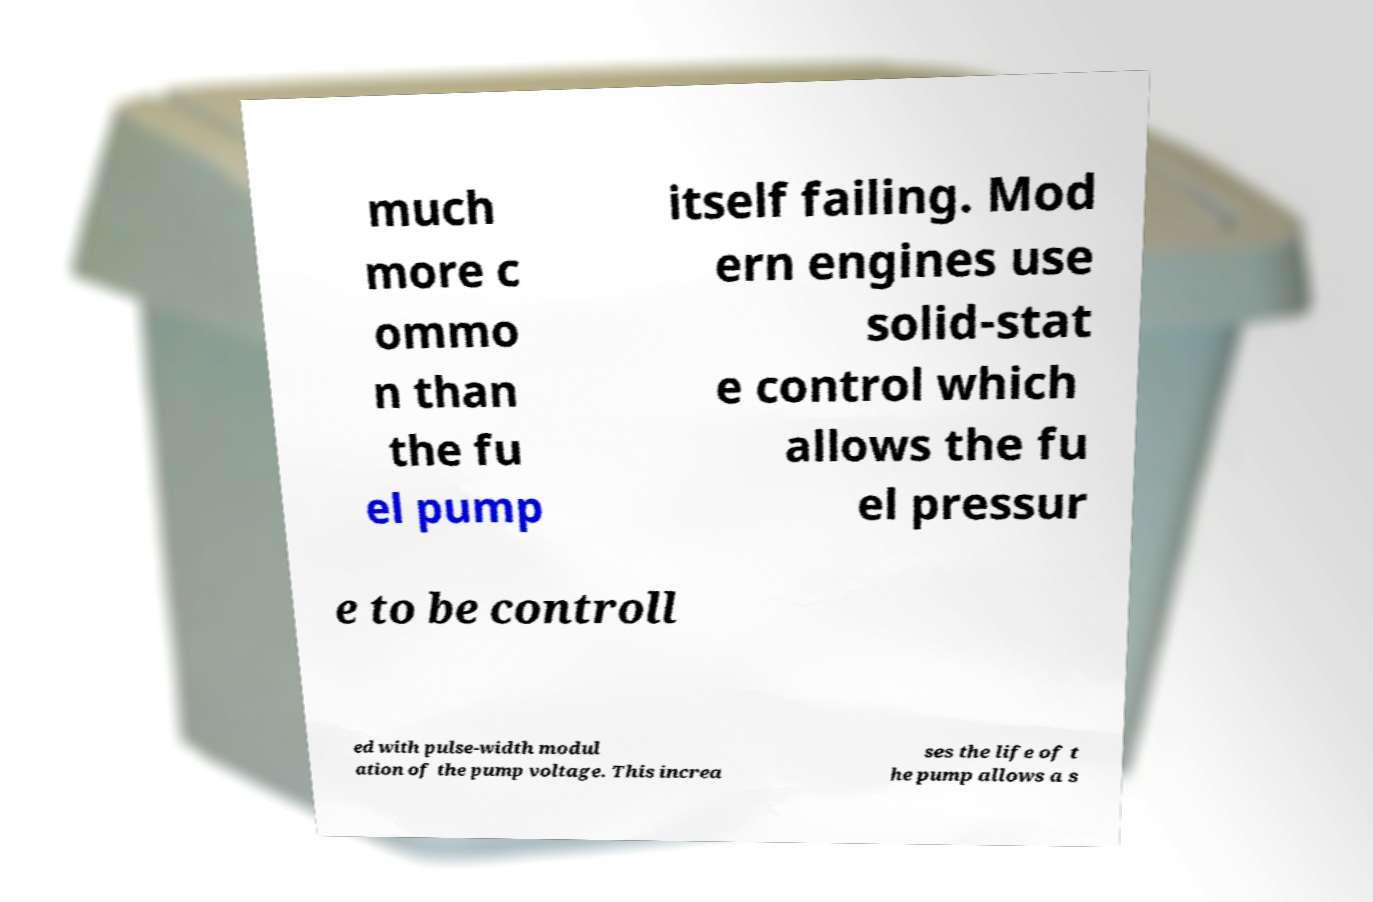Could you extract and type out the text from this image? much more c ommo n than the fu el pump itself failing. Mod ern engines use solid-stat e control which allows the fu el pressur e to be controll ed with pulse-width modul ation of the pump voltage. This increa ses the life of t he pump allows a s 